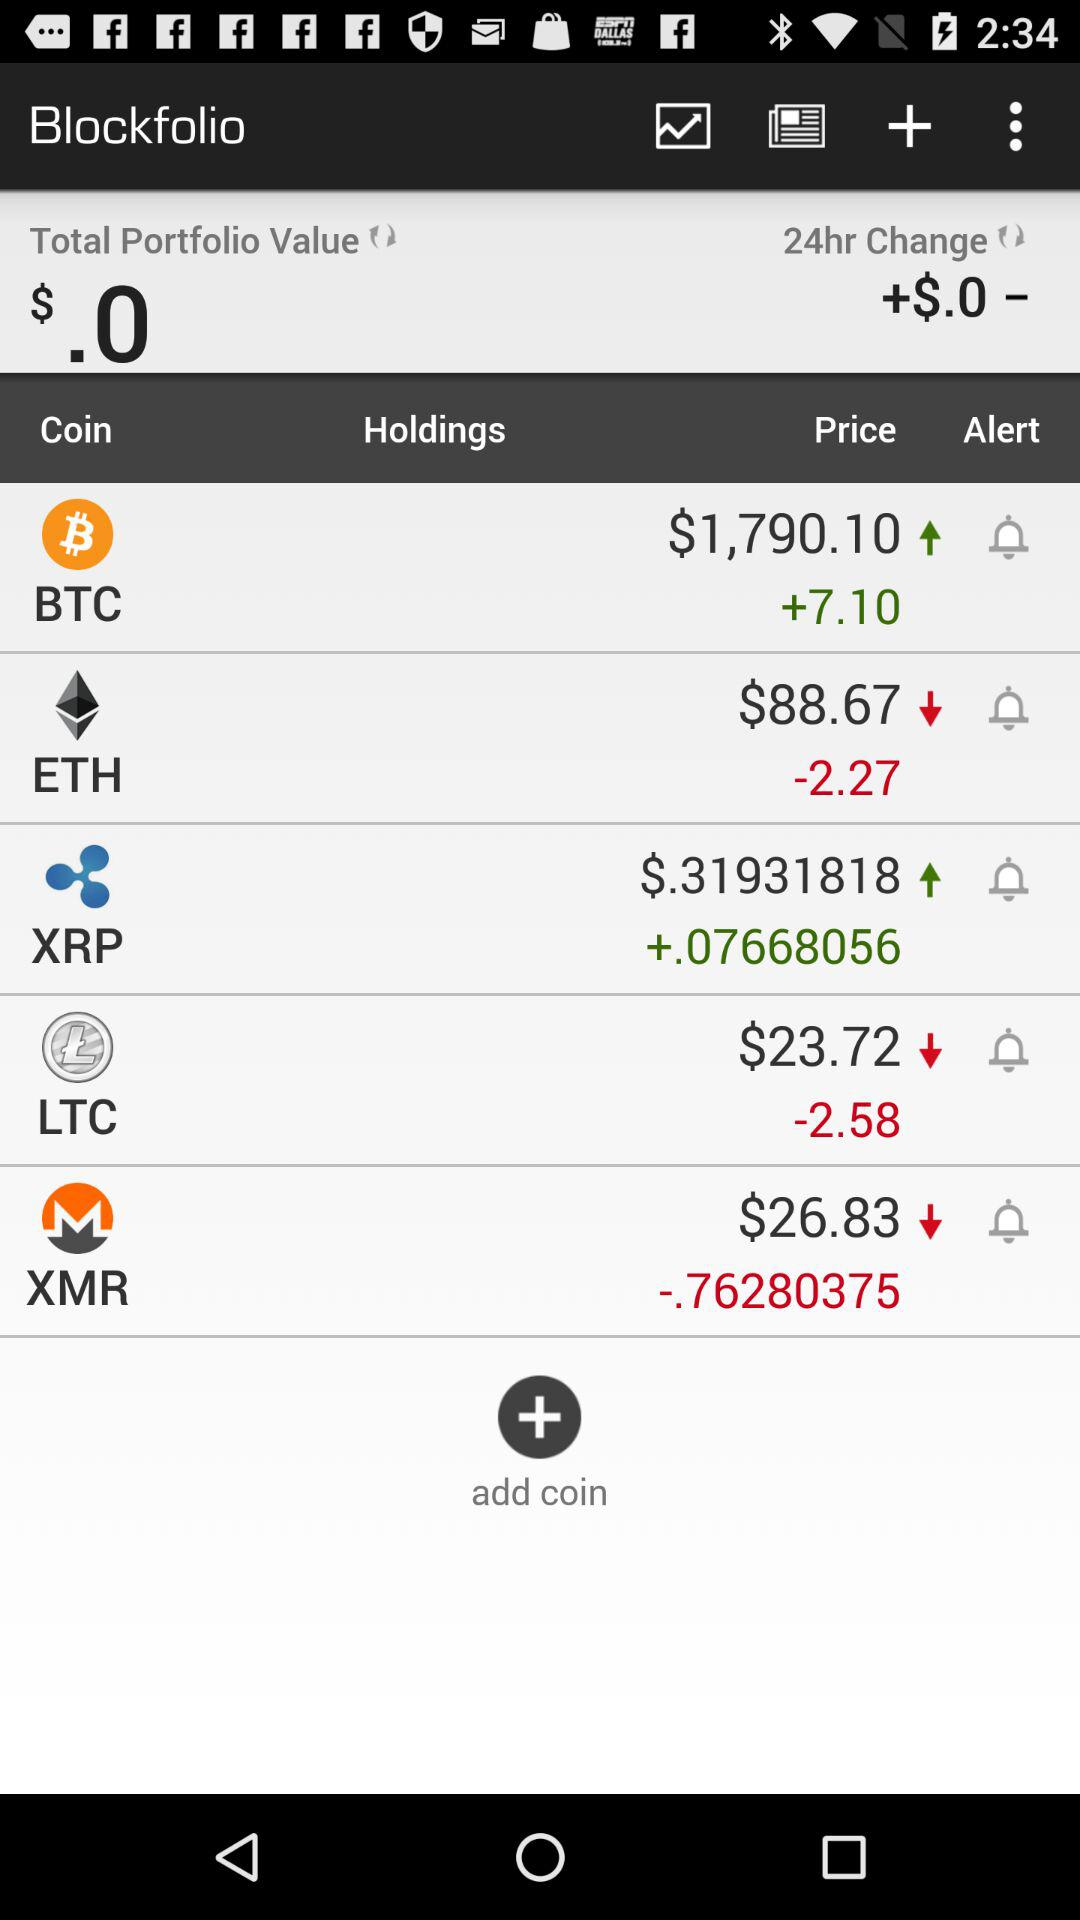How much is the price of the LTC coin? The price of the LTC coin is $23.72. 